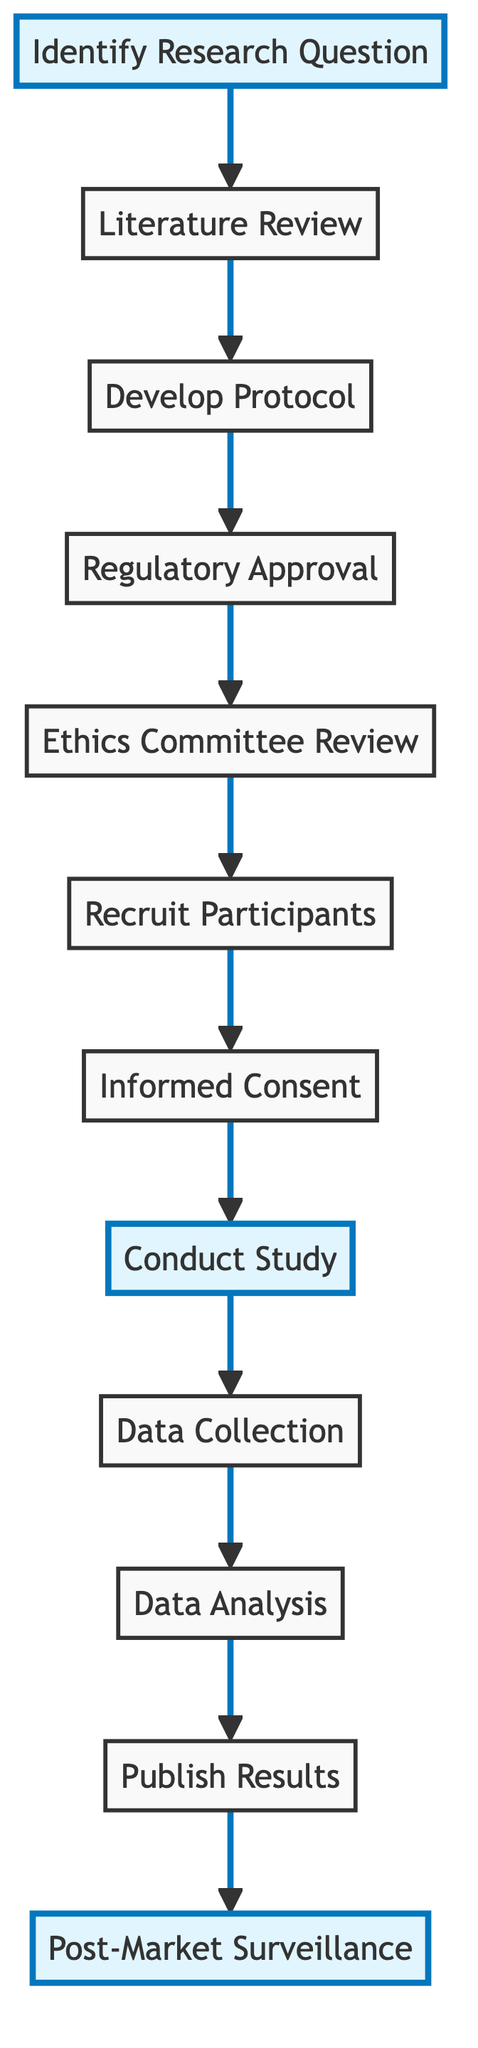What is the first step in the clinical trial process? The diagram indicates that the first step is "Identify Research Question." This is shown as the starting point in the flowchart.
Answer: Identify Research Question How many total steps are in the clinical trial process? By counting all the nodes in the diagram, we determine that there are a total of twelve steps listed from start to finish.
Answer: 12 What step comes after "Recruit Participants"? According to the flowchart, the next step following "Recruit Participants" is "Informed Consent." This is displayed directly connected to "Recruit Participants."
Answer: Informed Consent Which step is highlighted in the diagram? The flowchart indicates that three steps are highlighted: "Identify Research Question," "Conduct Study," and "Post-Market Surveillance," making them visually distinct from the others.
Answer: Identify Research Question, Conduct Study, Post-Market Surveillance What is the last step in the process? The last node of the flowchart represents "Post-Market Surveillance," which is the final step in the sequence. It is connected from the previous step "Publish Results."
Answer: Post-Market Surveillance What is the purpose of the "Ethics Committee Review"? The diagram describes "Ethics Committee Review" as the step where the study protocol is reviewed and approved by an Institutional Review Board (IRB) or Ethics Committee, ensuring ethical standards are met before proceeding.
Answer: Review and approval by an IRB or Ethics Committee Which two steps are directly connected in terms of order? "Regulatory Approval" and "Ethics Committee Review" are directly connected in the flow, indicating that "Ethics Committee Review" follows after "Regulatory Approval" in the sequence of conducting a clinical trial.
Answer: Regulatory Approval, Ethics Committee Review 